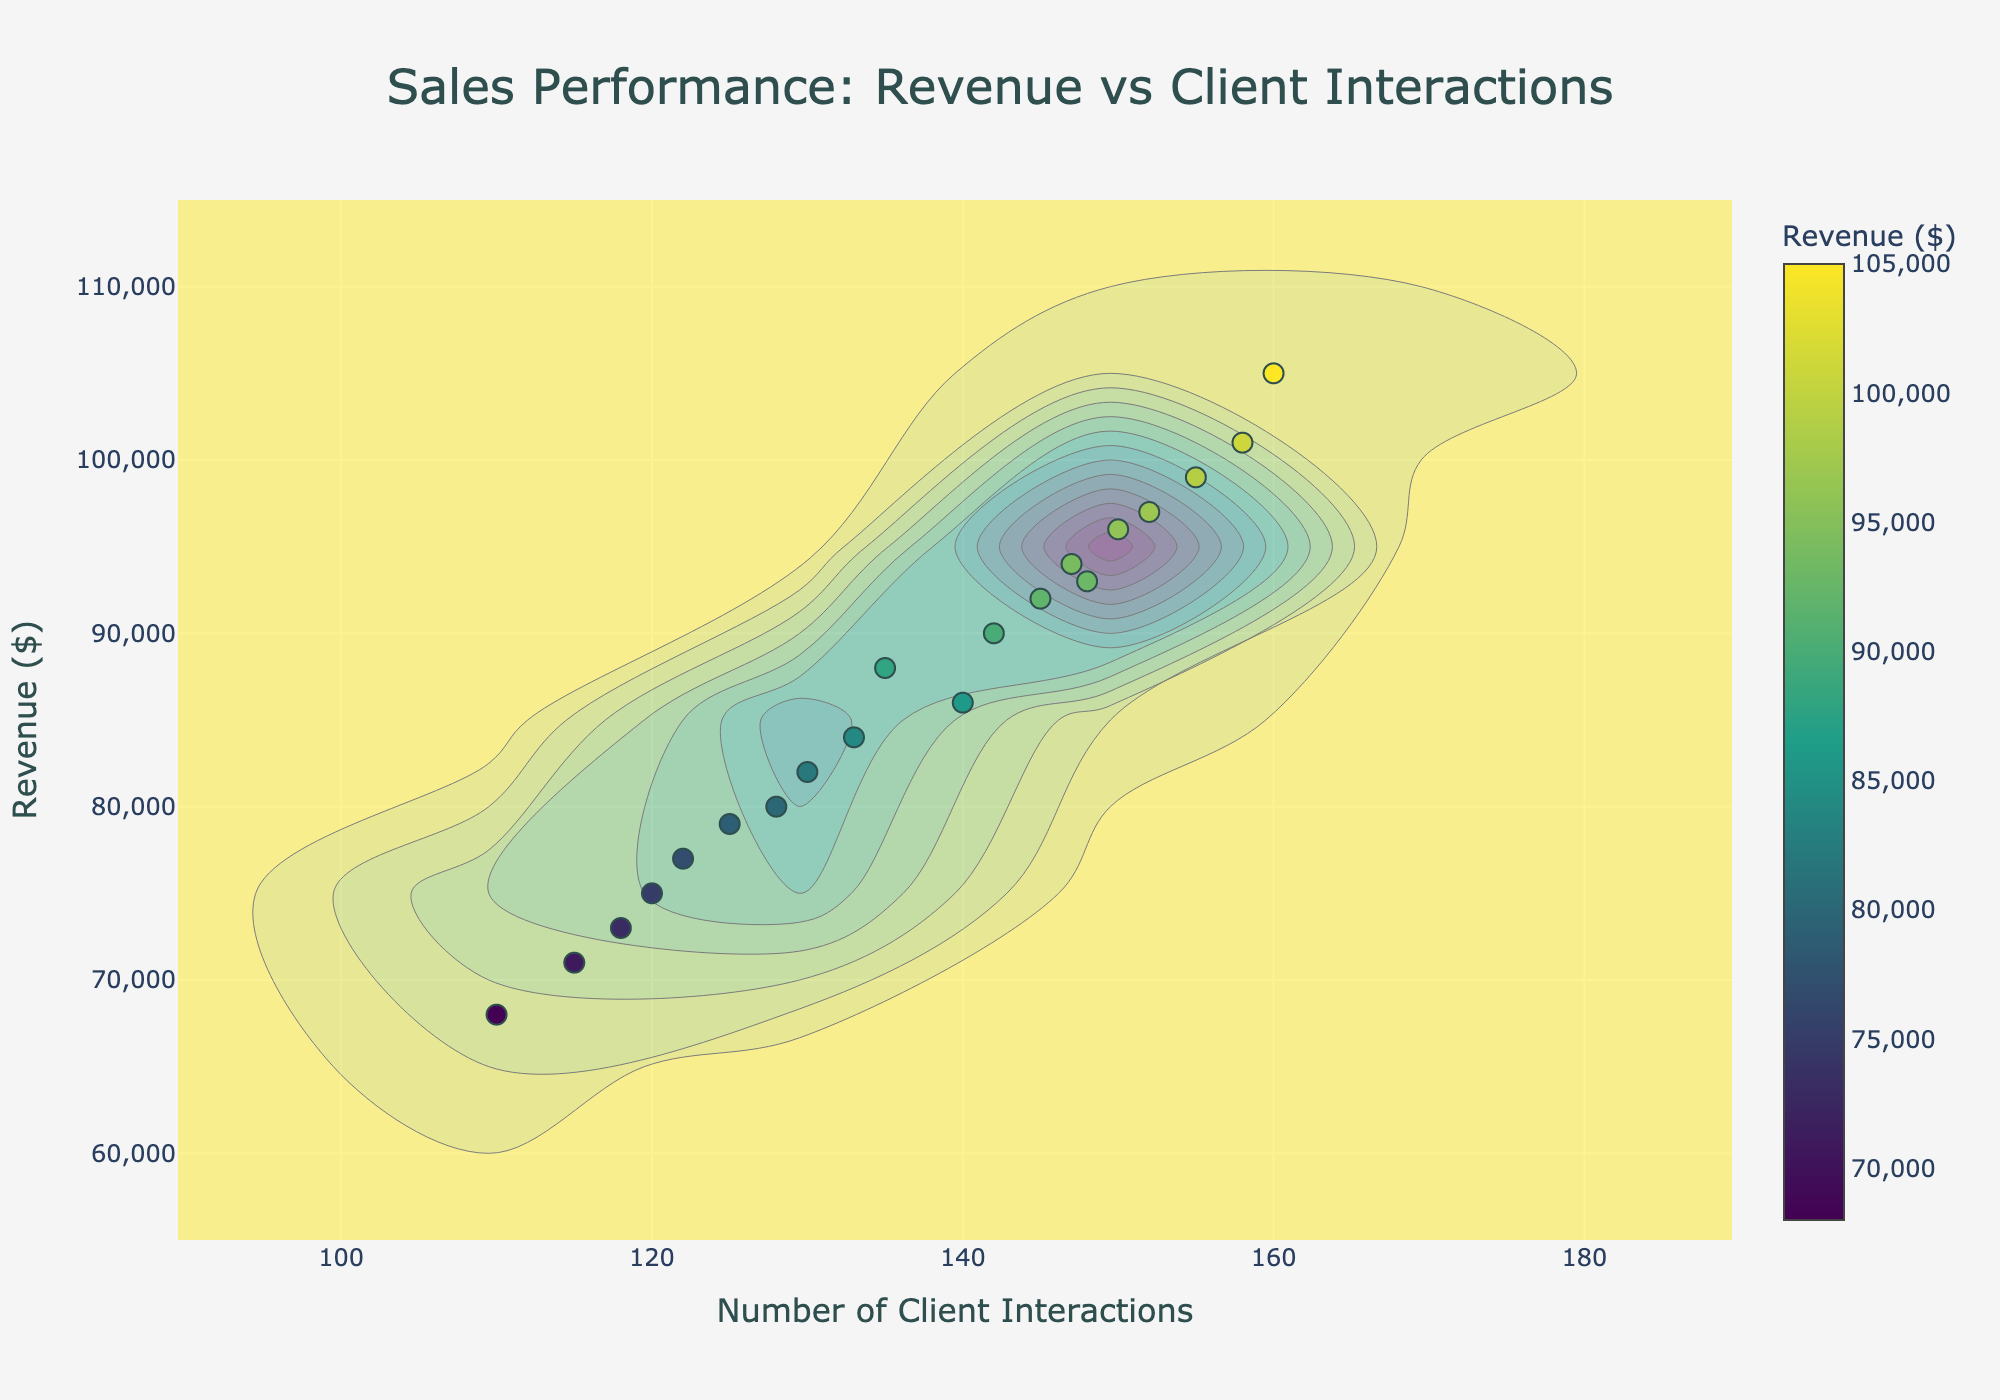How many sales representatives are represented in the plot? Count the number of unique data points which correspond to individual sales representatives.
Answer: 20 What is the title of the plot? The title is displayed at the center top of the plot.
Answer: Sales Performance: Revenue vs Client Interactions What is the color scale used in the plot? The color scale can be seen through the color bar, which transitions from one color to another to represent different revenue levels.
Answer: Viridis Which sales representative generated the highest revenue? Look for the data point with the highest y-value and hover over it to see the corresponding sales representative.
Answer: Robert Chen What's the range of client interactions shown on the x-axis? Look at the minimum and maximum values on the x-axis.
Answer: 110 to 160 Who generated more revenue, David Wilson or Emma Johnson? Find the data points for David Wilson and Emma Johnson, and compare their y-values.
Answer: Emma Johnson What is the average revenue for sales representatives with over 140 client interactions? Identify data points with x-values over 140, sum their y-values, and divide by the number of such data points.
Answer: $98,142.86 How many sales representatives have client interactions between 120 and 130? Count the number of data points that fall within the x-values of 120 to 130.
Answer: 4 Is there a noticeable correlation between the number of client interactions and the revenue generated? Observe the trend formed by the data points; a visible positive slope indicates a positive correlation.
Answer: Yes Which sales representative had the fewest client interactions but still generated more than $95,000 in revenue? Find the data point with the minimum x-value over 95,000 y-value and hover over it.
Answer: Sophia Patel 